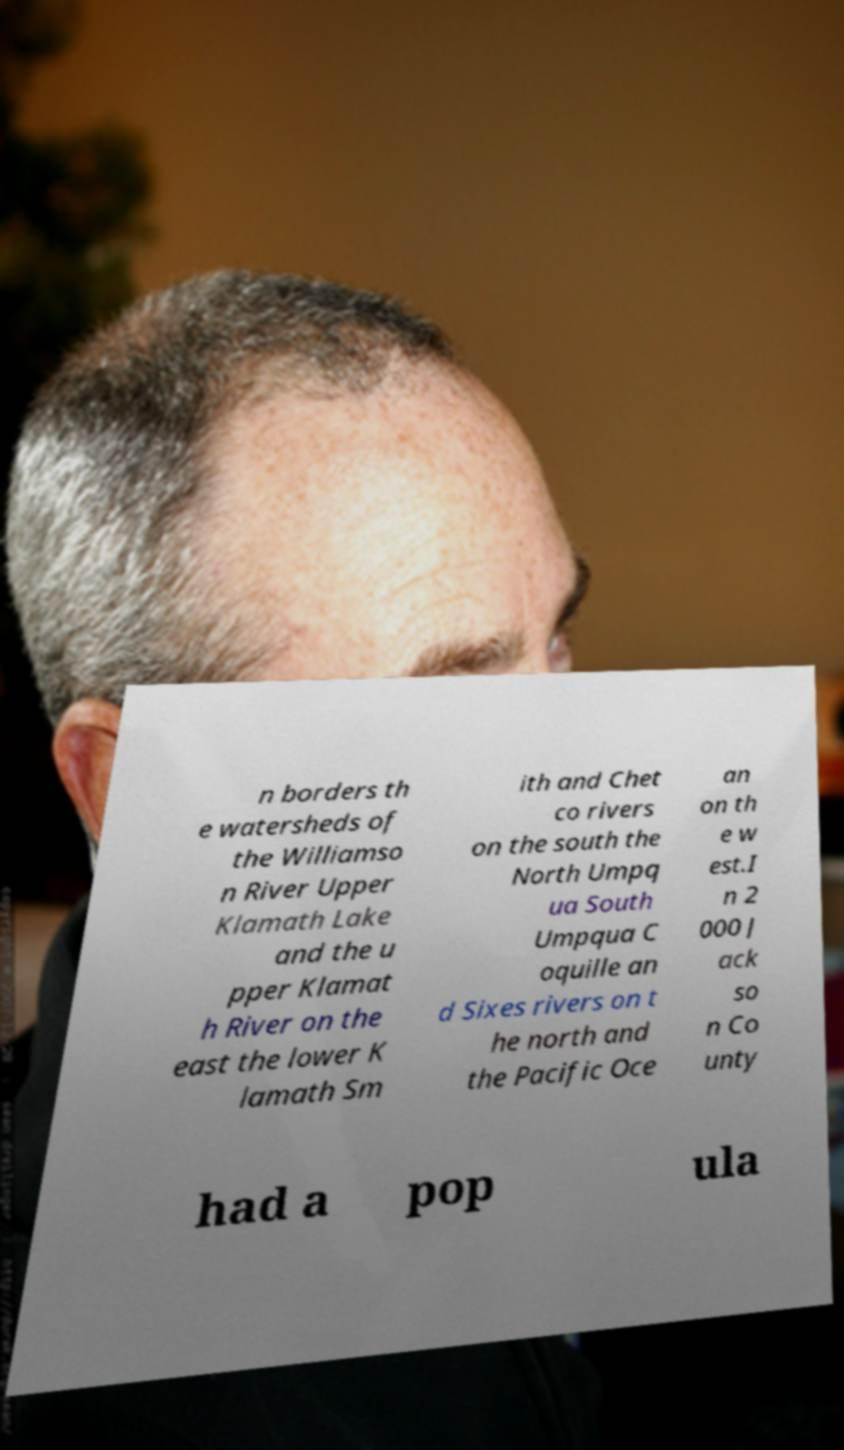Can you accurately transcribe the text from the provided image for me? n borders th e watersheds of the Williamso n River Upper Klamath Lake and the u pper Klamat h River on the east the lower K lamath Sm ith and Chet co rivers on the south the North Umpq ua South Umpqua C oquille an d Sixes rivers on t he north and the Pacific Oce an on th e w est.I n 2 000 J ack so n Co unty had a pop ula 